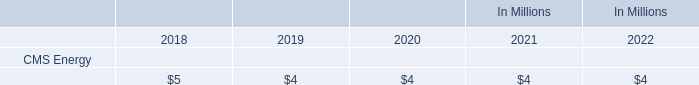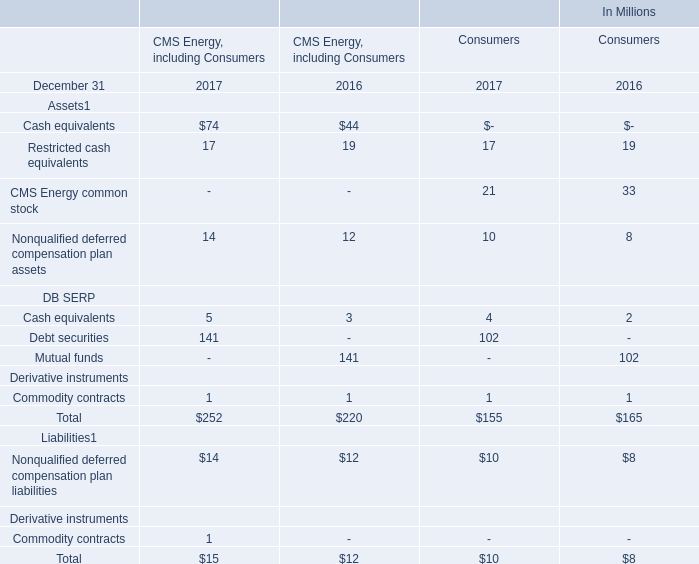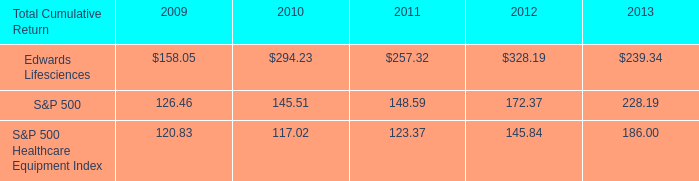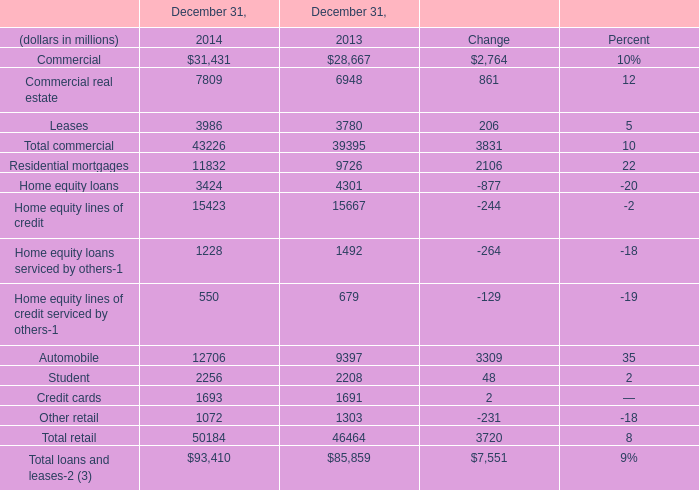What's the total amount of the Mutual funds in the years where Mutual funds is greater than 0? (in million) 
Computations: (141 + 102)
Answer: 243.0. 